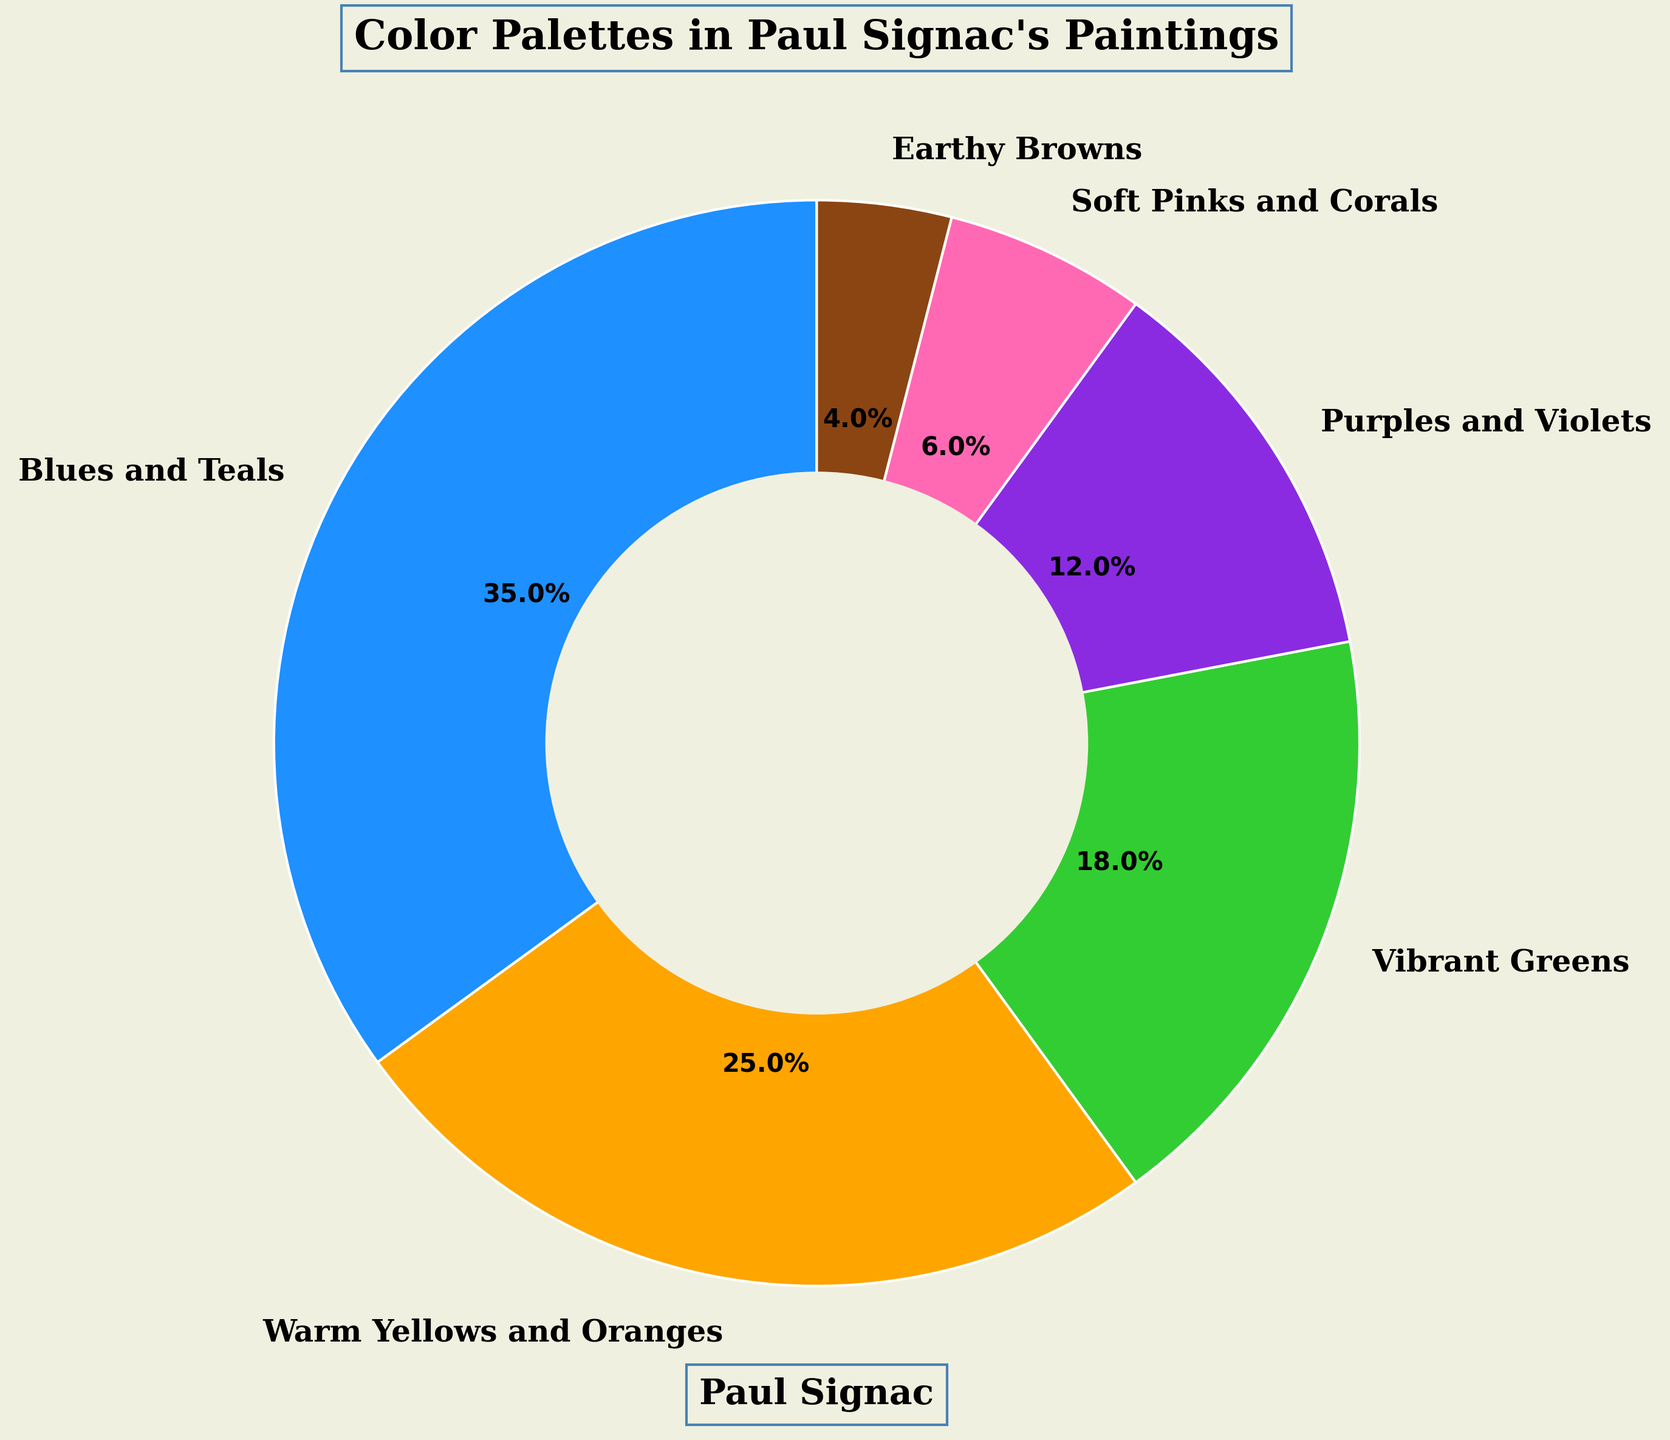What percentage of Signac's paintings use blues and teals? To find this, look directly at the pie chart section labeled "Blues and Teals" and read its percentage.
Answer: 35% Which color palette is used the least in Signac's paintings? Identify the smallest wedge in the pie chart and read the label and percentage associated with it.
Answer: Earthy Browns What is the combined percentage of paintings that use warm yellows and oranges, and vibrant greens? Add the percentages of the "Warm Yellows and Oranges" (25%) and "Vibrant Greens" (18%) sections from the pie chart. 25 + 18 = 43
Answer: 43% How does the usage of purples and violets compare to soft pinks and corals? Compare the percentage values of "Purples and Violets" (12%) and "Soft Pinks and Corals" (6%) by subtracting the smaller from the larger. 12 - 6 = 6
Answer: Purples and Violets are used 6% more Which color palette makes up nearly half as much usage as blues and teals? Look for the palette that has a percentage close to half of 35% (which is ~17.5%). "Vibrant Greens" fits this as its percentage is 18%.
Answer: Vibrant Greens What is the total percentage of Signac's paintings that do not use purples and violets? Subtract the percentage of "Purples and Violets" (12%) from 100%. 100 - 12 = 88
Answer: 88% If you combine the percentages of soft pinks and corals with earthy browns, how much percentage do they cover together? Add the percentages of "Soft Pinks and Corals" (6%) and "Earthy Browns" (4%) from the pie chart. 6 + 4 = 10
Answer: 10% What is the difference between the most used and the least used color palettes in Signac's paintings? Subtract the percentage of the least used palette "Earthy Browns" (4%) from the most used palette "Blues and Teals" (35%). 35 - 4 = 31
Answer: 31% Which three color palettes together make up more than half of Signac's paintings? Identify groups of three palettes whose combined percentage is greater than 50%. "Blues and Teals" (35%), "Warm Yellows and Oranges" (25%), and "Vibrant Greens" (18%) combined give 35 + 25 + 18 = 78
Answer: Blues and Teals, Warm Yellows and Oranges, Vibrant Greens Are there any color palettes used by Signac that are visually represented with a similar percentage on the chart? Which ones? Identify wedges that appear to have similar sizes. "Vibrant Greens" (18%) and "Purples and Violets" (12%) appear somewhat similar but not identical.
Answer: None are exactly similar 